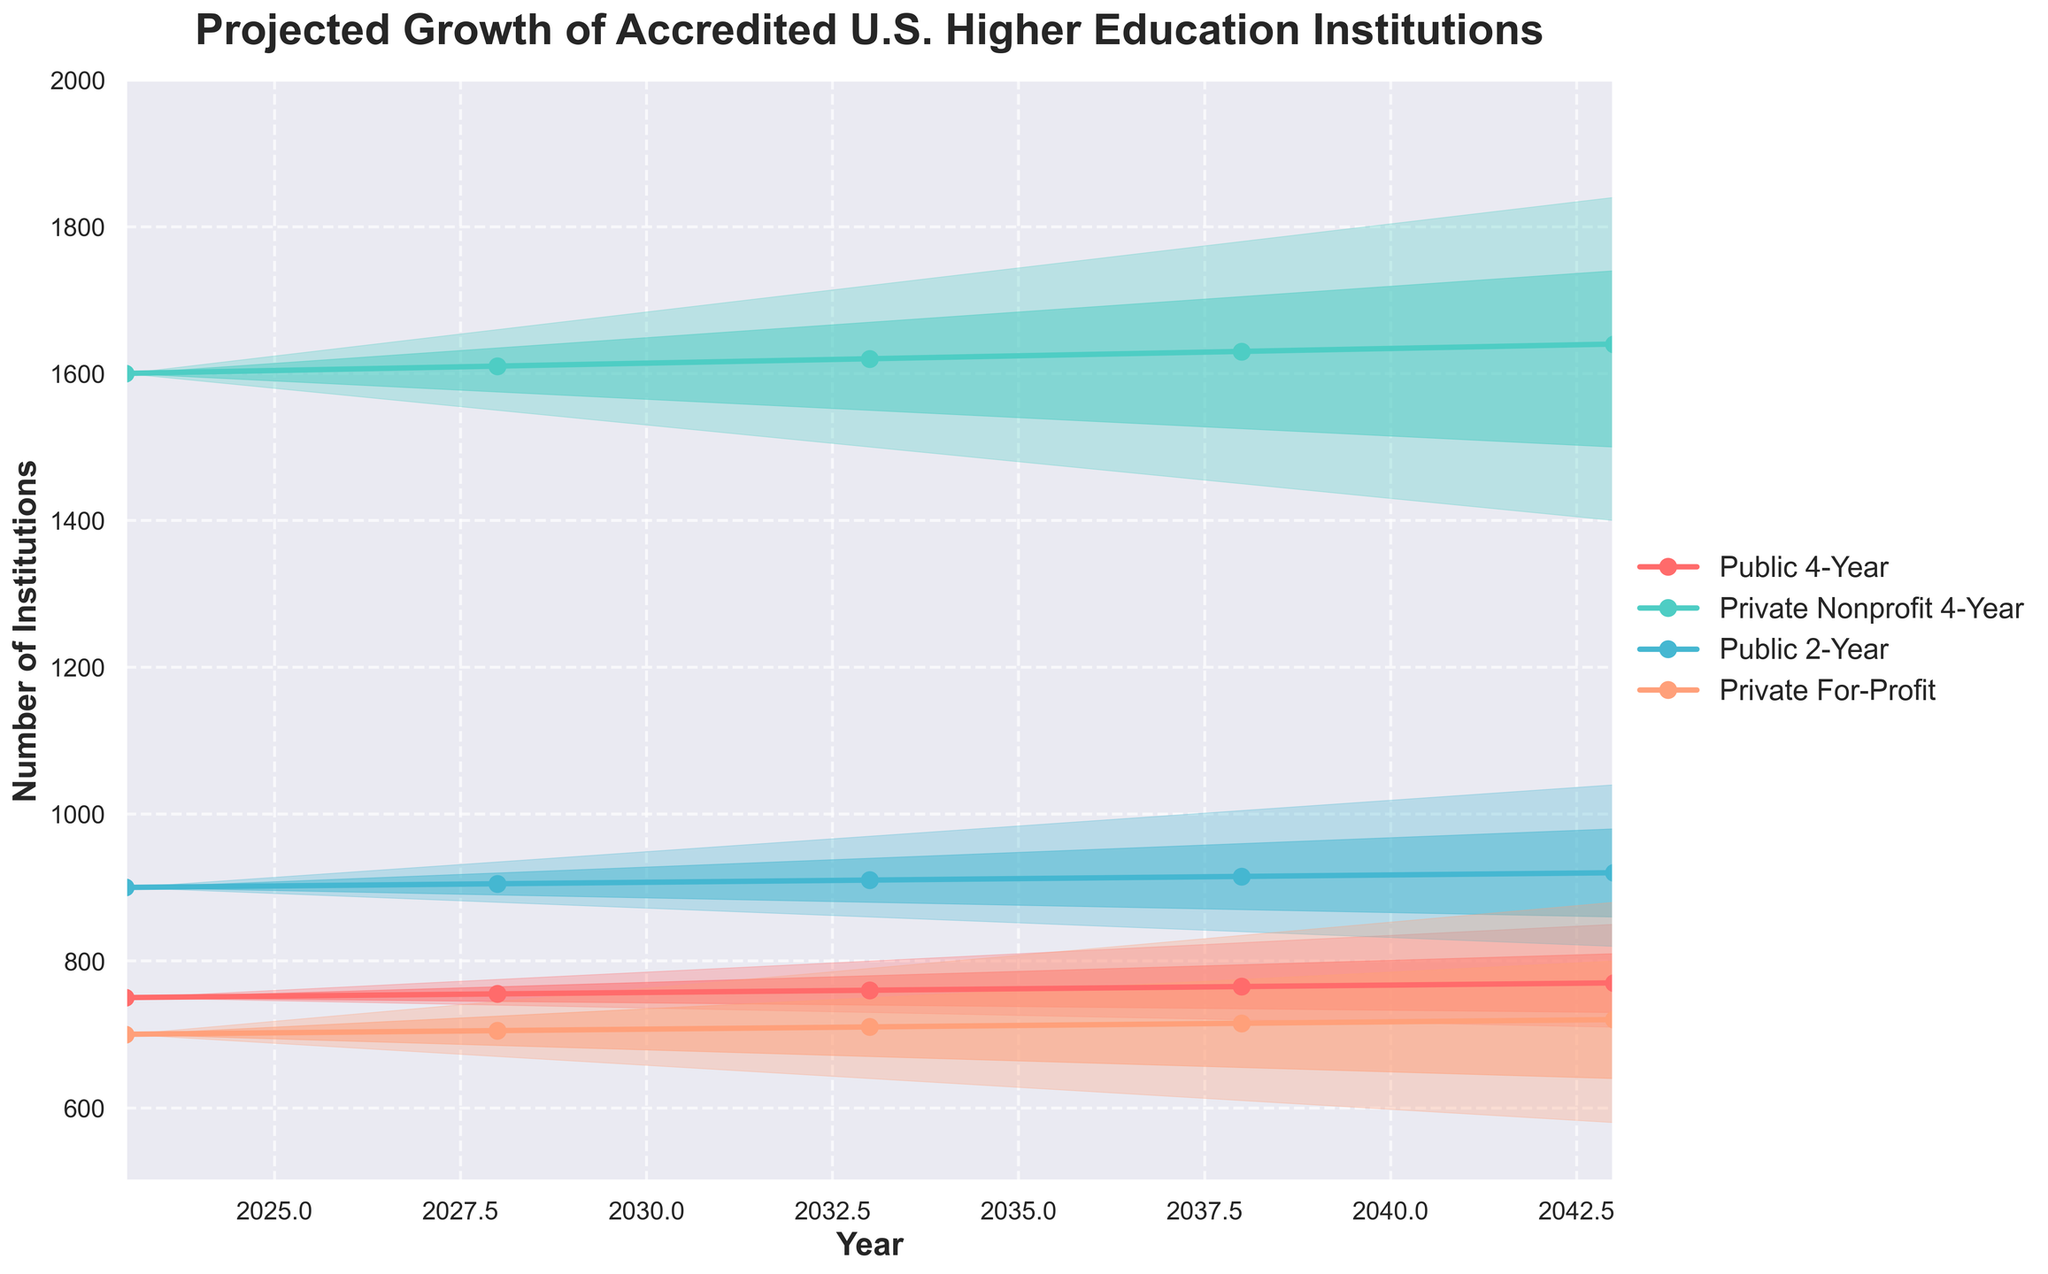What is the title of the chart? The title is displayed prominently at the top of the figure. It is "Projected Growth of Accredited U.S. Higher Education Institutions."
Answer: Projected Growth of Accredited U.S. Higher Education Institutions How many institution types are shown in the chart? The figure has different colors representing each type of institution. By counting the colors and labels in the legend, we can see there are four institution types.
Answer: 4 Which institution type has the highest middle estimate in 2043? By looking at the middle estimate lines (solid lines) in 2043 and comparing their values, the Private Nonprofit 4-Year institution type has the highest value, as indicated by the highest point in its range.
Answer: Private Nonprofit 4-Year How does the number of Private For-Profit institutions change from 2023 to 2043 according to the middle estimate? First, find the middle estimate for Private For-Profit institutions in 2023 (700) and then find it in 2043 (720). Then calculate the difference: 720 - 700 = 20.
Answer: Increases by 20 What is the range of estimates for Public 2-Year institutions in 2038? To find the range of estimates, look at the lowest and highest values for the year 2038 under Public 2-Year institutions. The low estimate is 840, and the high estimate is 1005. The range is thus 1005 - 840 = 165.
Answer: 165 What year shows the widest range for Private Nonprofit 4-Year institutions? By comparing the difference between the high and low estimates for Private Nonprofit 4-Year institutions across different years, we see that the year 2043 has the widest range (1840 - 1400 = 440).
Answer: 2043 Which institution type shows a decrease in all estimates from 2023 to 2043? By comparing the trends of all estimates from 2023 to 2043 for each institution type, Public 4-Year shows a consistent decrease across low, lower middle, middle, upper middle, and high estimates.
Answer: Public 4-Year In which year do the Upper Middle estimates for Public and Private Nonprofit 4-Year institutions first intersect? To find the intersection, check the values of the Upper Middle estimates for both institution types across all years. They first intersect in 2028, where both have an upper middle estimate around 765.
Answer: 2028 What is the high estimate for Private For-Profit institutions in 2028? The high estimate can be found by looking at the top boundary of the shaded area for Private For-Profit institutions in 2028. This value is 745.
Answer: 745 